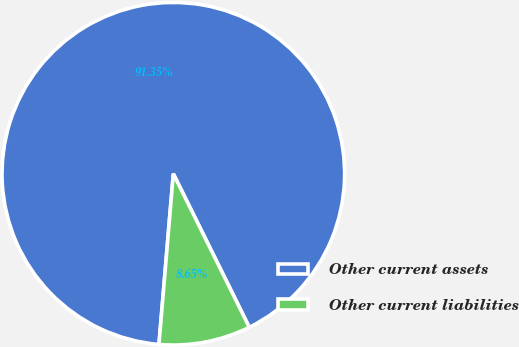<chart> <loc_0><loc_0><loc_500><loc_500><pie_chart><fcel>Other current assets<fcel>Other current liabilities<nl><fcel>91.35%<fcel>8.65%<nl></chart> 